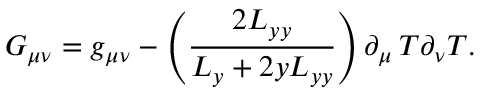Convert formula to latex. <formula><loc_0><loc_0><loc_500><loc_500>G _ { \mu \nu } = g _ { \mu \nu } - \left ( \frac { 2 L _ { y y } } { L _ { y } + 2 y L _ { y y } } \right ) \partial _ { \mu } T \partial _ { \nu } T .</formula> 